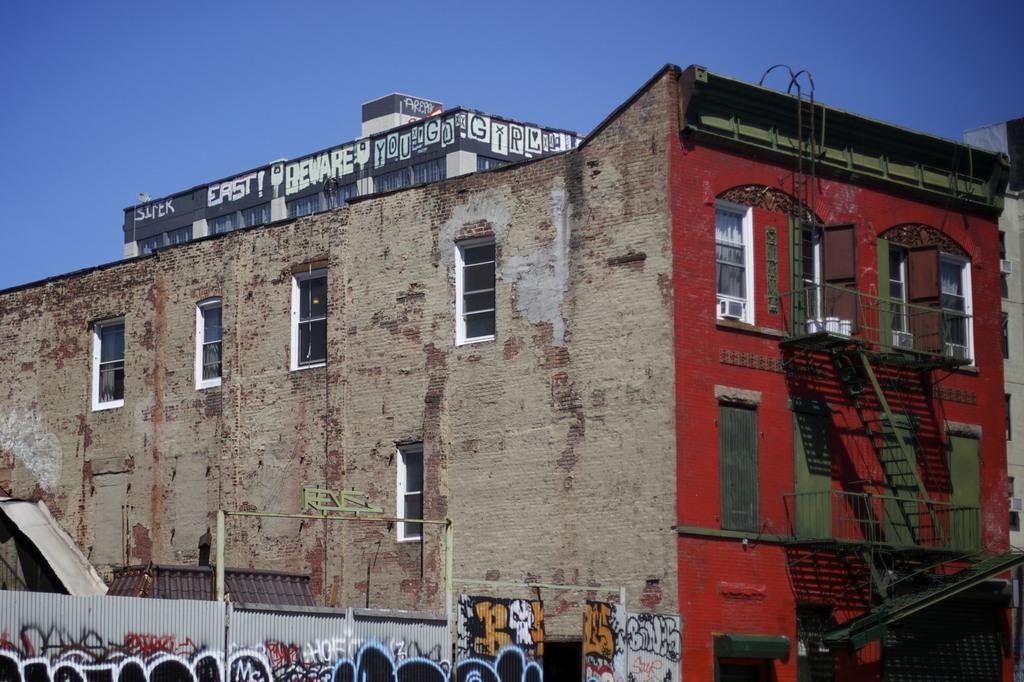In one or two sentences, can you explain what this image depicts? In this picture I can see the building. I can see glass windows I can see railings and stairs on the right side. I can see roofing sheet fence on the left side. I can see the sky is clear. 